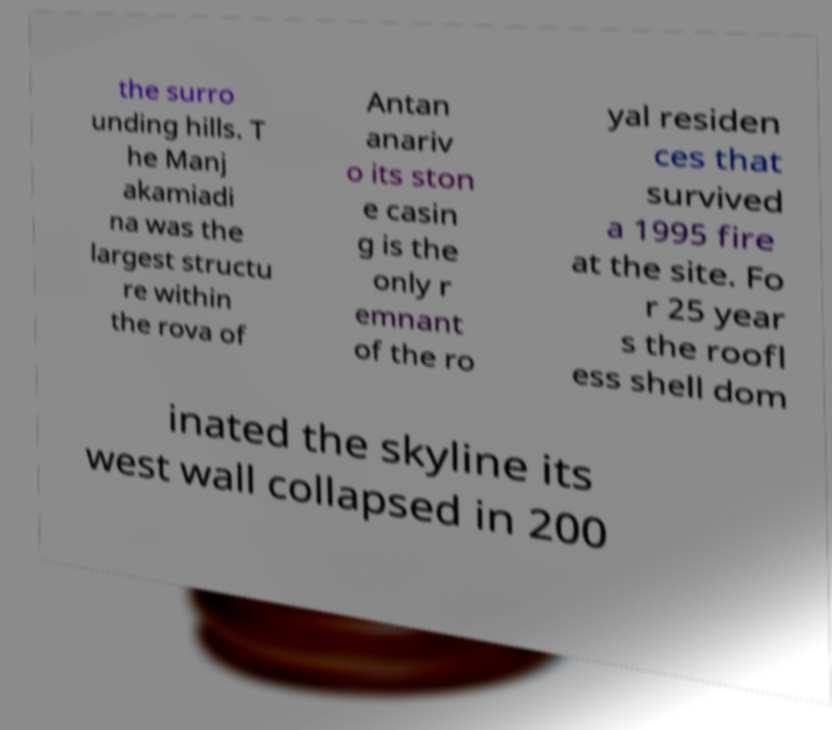Could you extract and type out the text from this image? the surro unding hills. T he Manj akamiadi na was the largest structu re within the rova of Antan anariv o its ston e casin g is the only r emnant of the ro yal residen ces that survived a 1995 fire at the site. Fo r 25 year s the roofl ess shell dom inated the skyline its west wall collapsed in 200 